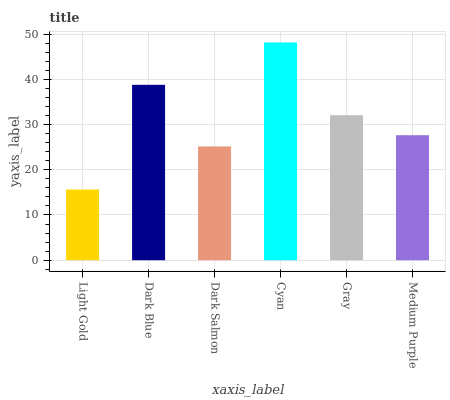Is Light Gold the minimum?
Answer yes or no. Yes. Is Cyan the maximum?
Answer yes or no. Yes. Is Dark Blue the minimum?
Answer yes or no. No. Is Dark Blue the maximum?
Answer yes or no. No. Is Dark Blue greater than Light Gold?
Answer yes or no. Yes. Is Light Gold less than Dark Blue?
Answer yes or no. Yes. Is Light Gold greater than Dark Blue?
Answer yes or no. No. Is Dark Blue less than Light Gold?
Answer yes or no. No. Is Gray the high median?
Answer yes or no. Yes. Is Medium Purple the low median?
Answer yes or no. Yes. Is Dark Blue the high median?
Answer yes or no. No. Is Dark Blue the low median?
Answer yes or no. No. 